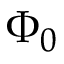Convert formula to latex. <formula><loc_0><loc_0><loc_500><loc_500>\Phi _ { 0 }</formula> 